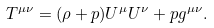Convert formula to latex. <formula><loc_0><loc_0><loc_500><loc_500>T ^ { \mu \nu } = ( \rho + p ) U ^ { \mu } U ^ { \nu } + p g ^ { \mu \nu } .</formula> 